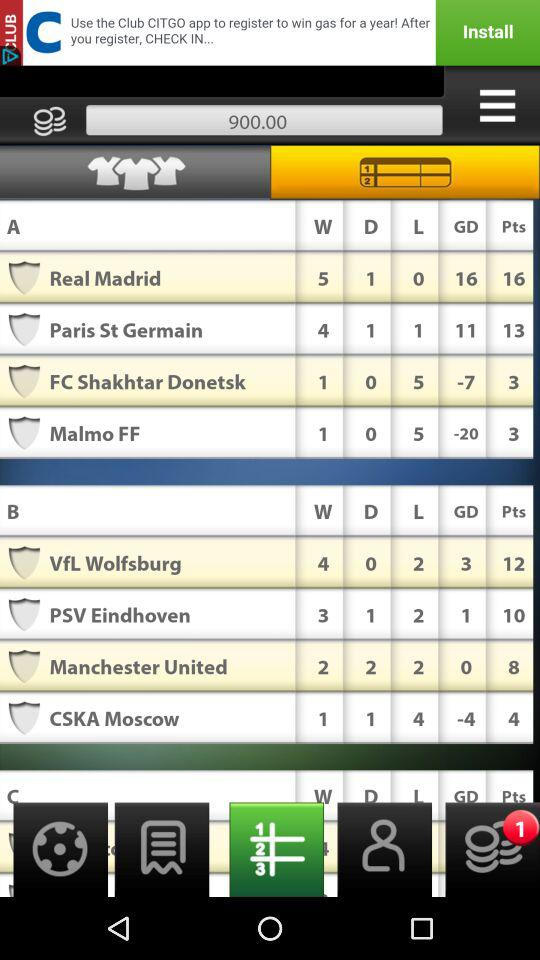How many total points does "CSKA Moscow" contain? "CSKA Moscow" has a total of 4 points. 